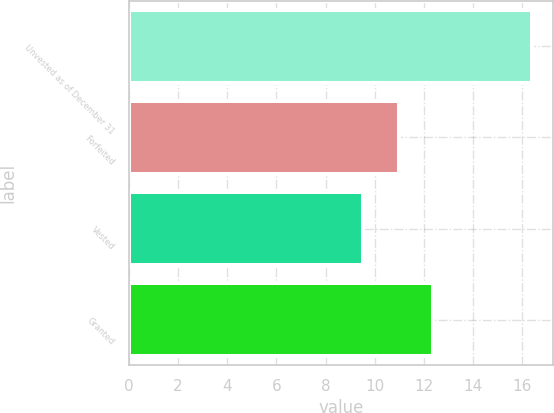Convert chart. <chart><loc_0><loc_0><loc_500><loc_500><bar_chart><fcel>Unvested as of December 31<fcel>Forfeited<fcel>Vested<fcel>Granted<nl><fcel>16.41<fcel>11<fcel>9.51<fcel>12.38<nl></chart> 